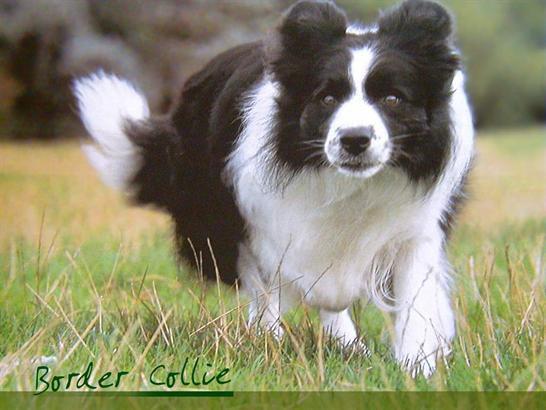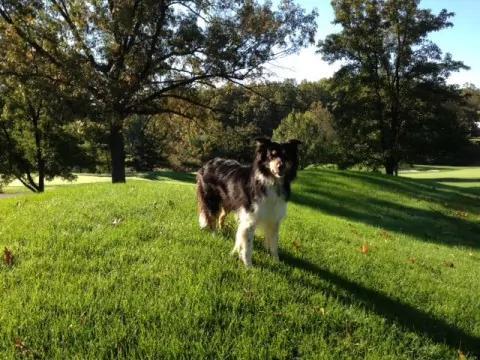The first image is the image on the left, the second image is the image on the right. Examine the images to the left and right. Is the description "The right image shows only one animal." accurate? Answer yes or no. Yes. The first image is the image on the left, the second image is the image on the right. Analyze the images presented: Is the assertion "At least one image features only a black and white dog, with no livestock." valid? Answer yes or no. Yes. 